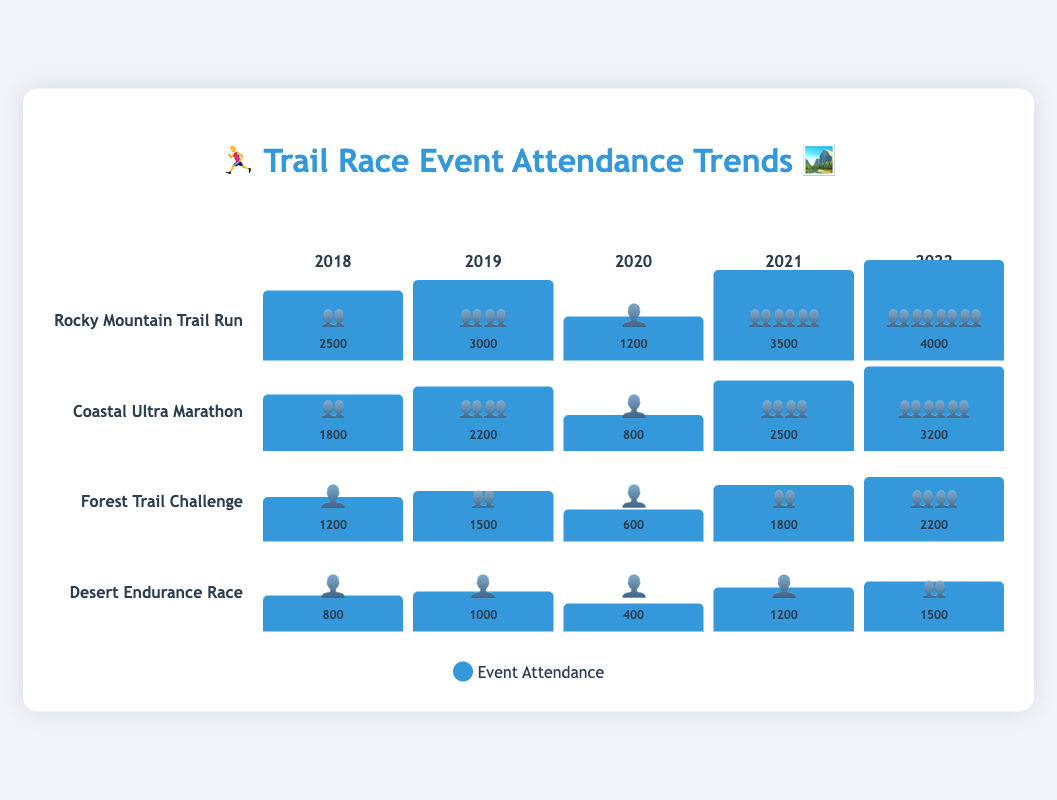What's the attendance trend for the "Rocky Mountain Trail Run" from 2018 to 2022? To determine the trend, observe the heights of the bars representing each year and the corresponding attendance figures. The attendance increases from 2500 in 2018 to 4000 in 2022.
Answer: Increasing Which year had the lowest attendance for "Forest Trail Challenge"? Identify the bar with the smallest height and emoji for "Forest Trail Challenge", and check its attendance value. The year 2020 has the lowest attendance at 600.
Answer: 2020 How did the "Desert Endurance Race" attendance change from 2020 to 2021? Compare the height and emoji of the bars for 2020 and 2021 for "Desert Endurance Race". The attendance went from 400 in 2020 to 1200 in 2021, showing an increase.
Answer: Increased Which event had the highest attendance in 2022? Compare the heights of the bars and emojis for all events in the year 2022. "Rocky Mountain Trail Run" had the highest attendance at 4000.
Answer: Rocky Mountain Trail Run How does the attendance of "Coastal Ultra Marathon" in 2020 compare with 2021? Look at the bar heights and emojis for "Coastal Ultra Marathon" in 2020 and 2021. The attendance in 2020 was 800, significantly lower than 2500 in 2021.
Answer: Higher in 2021 What's the difference in attendance between the "Rocky Mountain Trail Run" and "Desert Endurance Race" in 2018? Calculate the difference by subtracting the attendance of "Desert Endurance Race" from that of "Rocky Mountain Trail Run" in 2018. (2500 - 800 = 1700)
Answer: 1700 Which event showed the greatest relative increase in attendance from 2020 to 2022? Calculate the percentage increase for each event from 2020 to 2022. The "Rocky Mountain Trail Run" increased from 1200 to 4000, which is the highest relative increase among all events.
Answer: Rocky Mountain Trail Run What is the average attendance of "Coastal Ultra Marathon" over the 5 years? Sum the attendance values over the 5 years and divide by the number of years. (1800 + 2200 + 800 + 2500 + 3200) / 5 = 10500 / 5 = 2100
Answer: 2100 Which event had the least variation in attendance over the years? Evaluate the differences in the bar heights (and attendance) for each event over the years and compare. The "Forest Trail Challenge" shows the least variation compared to the others.
Answer: Forest Trail Challenge 